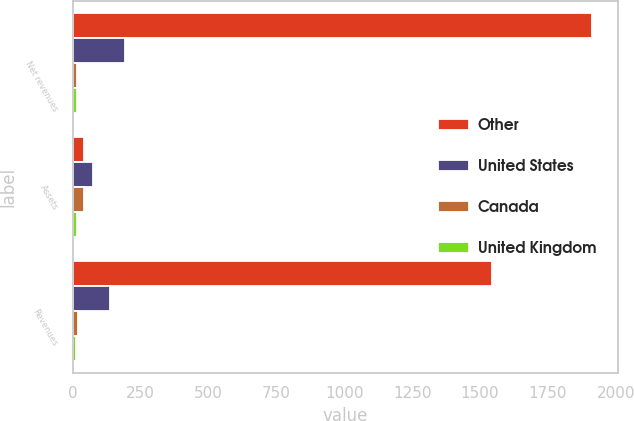Convert chart. <chart><loc_0><loc_0><loc_500><loc_500><stacked_bar_chart><ecel><fcel>Net revenues<fcel>Assets<fcel>Revenues<nl><fcel>Other<fcel>1911.5<fcel>42<fcel>1545.7<nl><fcel>United States<fcel>192.7<fcel>75.7<fcel>138.1<nl><fcel>Canada<fcel>16.9<fcel>42<fcel>18.9<nl><fcel>United Kingdom<fcel>16.8<fcel>17.5<fcel>14.4<nl></chart> 